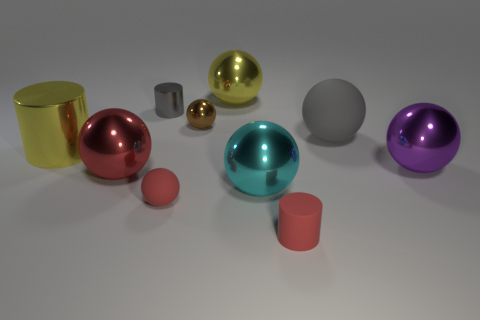Do the cyan ball and the gray metal cylinder have the same size?
Your response must be concise. No. Is the number of large yellow balls behind the large gray ball the same as the number of tiny gray metallic things?
Your answer should be very brief. Yes. Is there a yellow thing that is on the left side of the matte ball left of the tiny matte cylinder?
Ensure brevity in your answer.  Yes. What is the size of the gray object to the left of the cylinder on the right side of the tiny matte object behind the small matte cylinder?
Your answer should be compact. Small. What material is the gray thing to the right of the rubber ball that is left of the large matte thing made of?
Offer a very short reply. Rubber. Is there a large gray rubber thing that has the same shape as the brown shiny object?
Give a very brief answer. Yes. What is the shape of the tiny gray metallic thing?
Ensure brevity in your answer.  Cylinder. There is a gray object left of the large yellow metallic object behind the yellow metallic thing that is in front of the small gray cylinder; what is it made of?
Keep it short and to the point. Metal. Are there more brown things that are to the left of the brown metallic thing than tiny cylinders?
Provide a succinct answer. No. There is a yellow sphere that is the same size as the cyan metallic object; what is its material?
Give a very brief answer. Metal. 